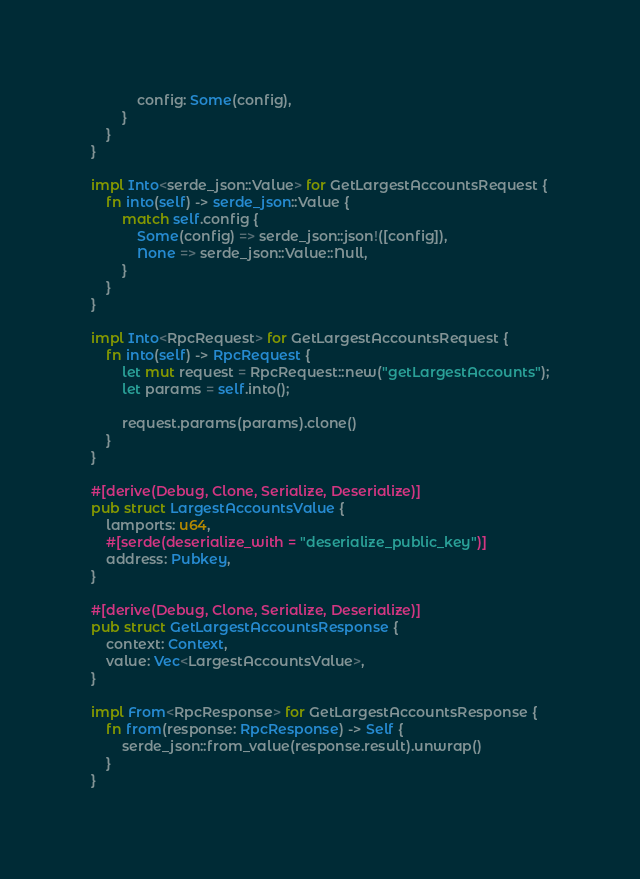<code> <loc_0><loc_0><loc_500><loc_500><_Rust_>            config: Some(config),
        }
    }
}

impl Into<serde_json::Value> for GetLargestAccountsRequest {
    fn into(self) -> serde_json::Value {
        match self.config {
            Some(config) => serde_json::json!([config]),
            None => serde_json::Value::Null,
        }
    }
}

impl Into<RpcRequest> for GetLargestAccountsRequest {
    fn into(self) -> RpcRequest {
        let mut request = RpcRequest::new("getLargestAccounts");
        let params = self.into();

        request.params(params).clone()
    }
}

#[derive(Debug, Clone, Serialize, Deserialize)]
pub struct LargestAccountsValue {
    lamports: u64,
    #[serde(deserialize_with = "deserialize_public_key")]
    address: Pubkey,
}

#[derive(Debug, Clone, Serialize, Deserialize)]
pub struct GetLargestAccountsResponse {
    context: Context,
    value: Vec<LargestAccountsValue>,
}

impl From<RpcResponse> for GetLargestAccountsResponse {
    fn from(response: RpcResponse) -> Self {
        serde_json::from_value(response.result).unwrap()
    }
}
</code> 